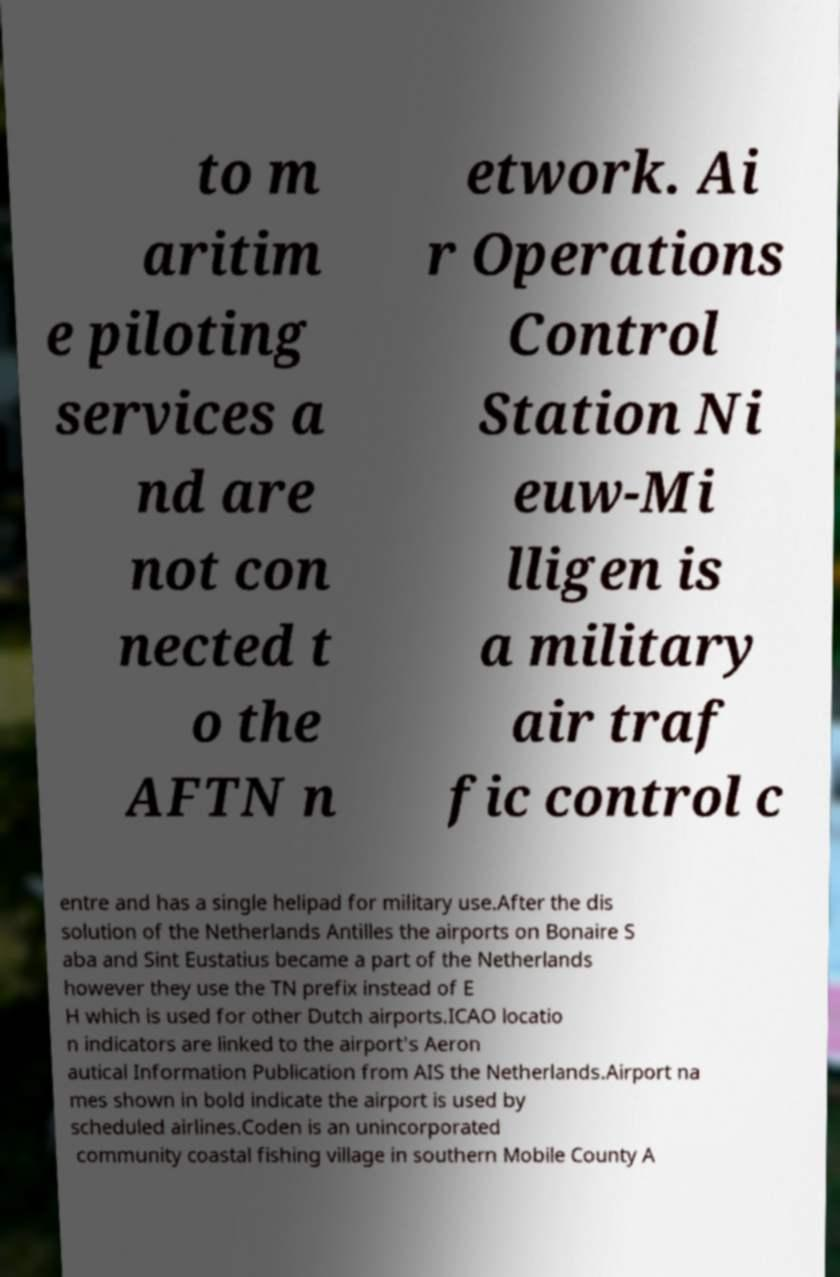Please identify and transcribe the text found in this image. to m aritim e piloting services a nd are not con nected t o the AFTN n etwork. Ai r Operations Control Station Ni euw-Mi lligen is a military air traf fic control c entre and has a single helipad for military use.After the dis solution of the Netherlands Antilles the airports on Bonaire S aba and Sint Eustatius became a part of the Netherlands however they use the TN prefix instead of E H which is used for other Dutch airports.ICAO locatio n indicators are linked to the airport's Aeron autical Information Publication from AIS the Netherlands.Airport na mes shown in bold indicate the airport is used by scheduled airlines.Coden is an unincorporated community coastal fishing village in southern Mobile County A 